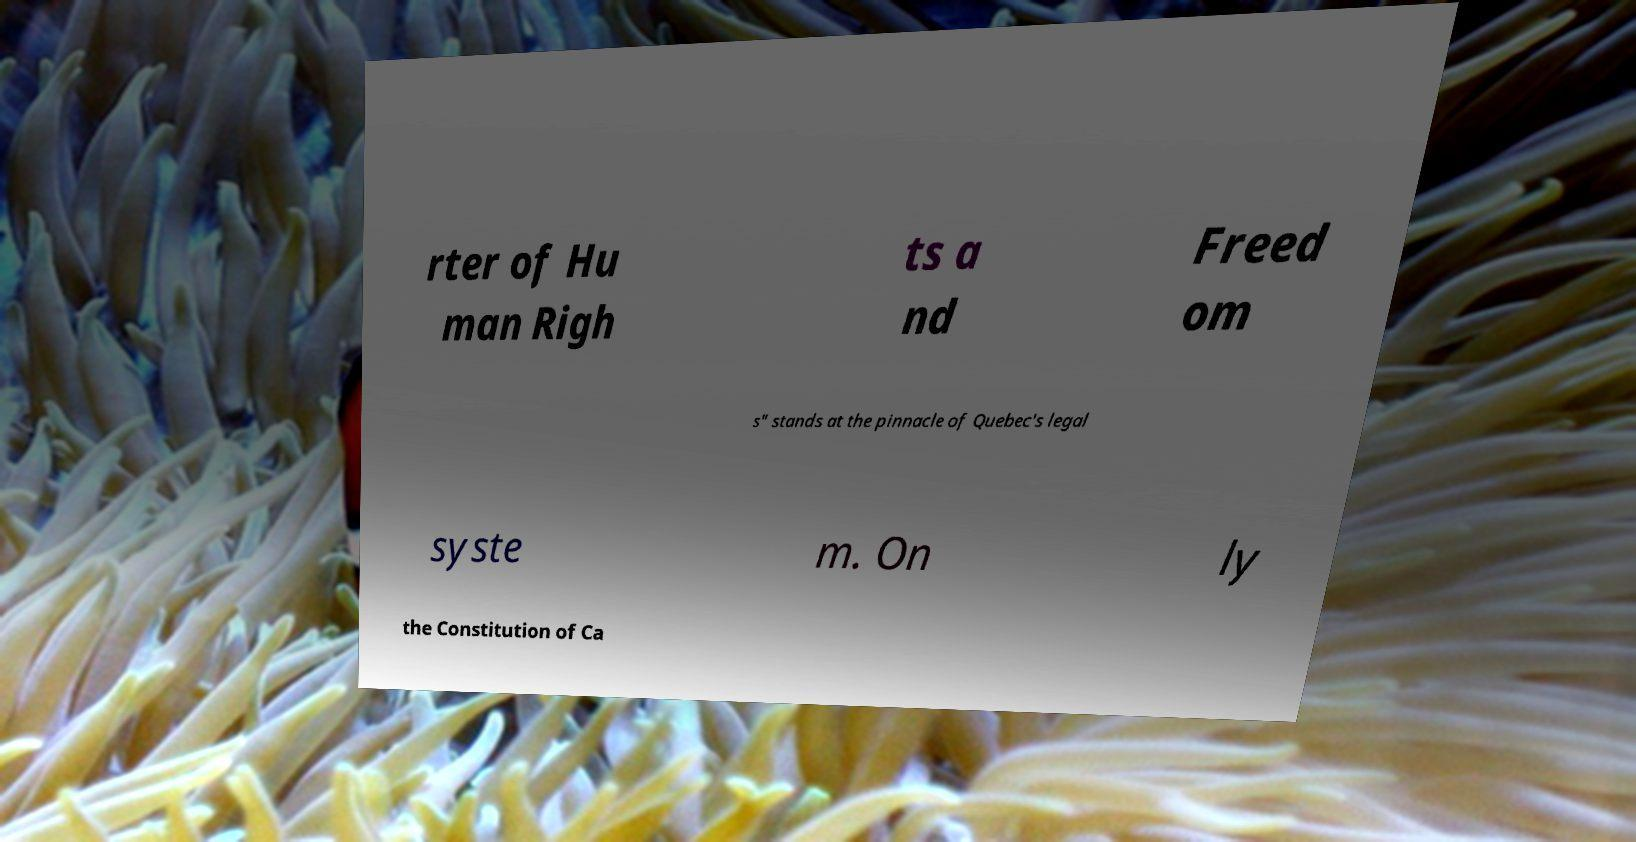Could you extract and type out the text from this image? rter of Hu man Righ ts a nd Freed om s" stands at the pinnacle of Quebec's legal syste m. On ly the Constitution of Ca 